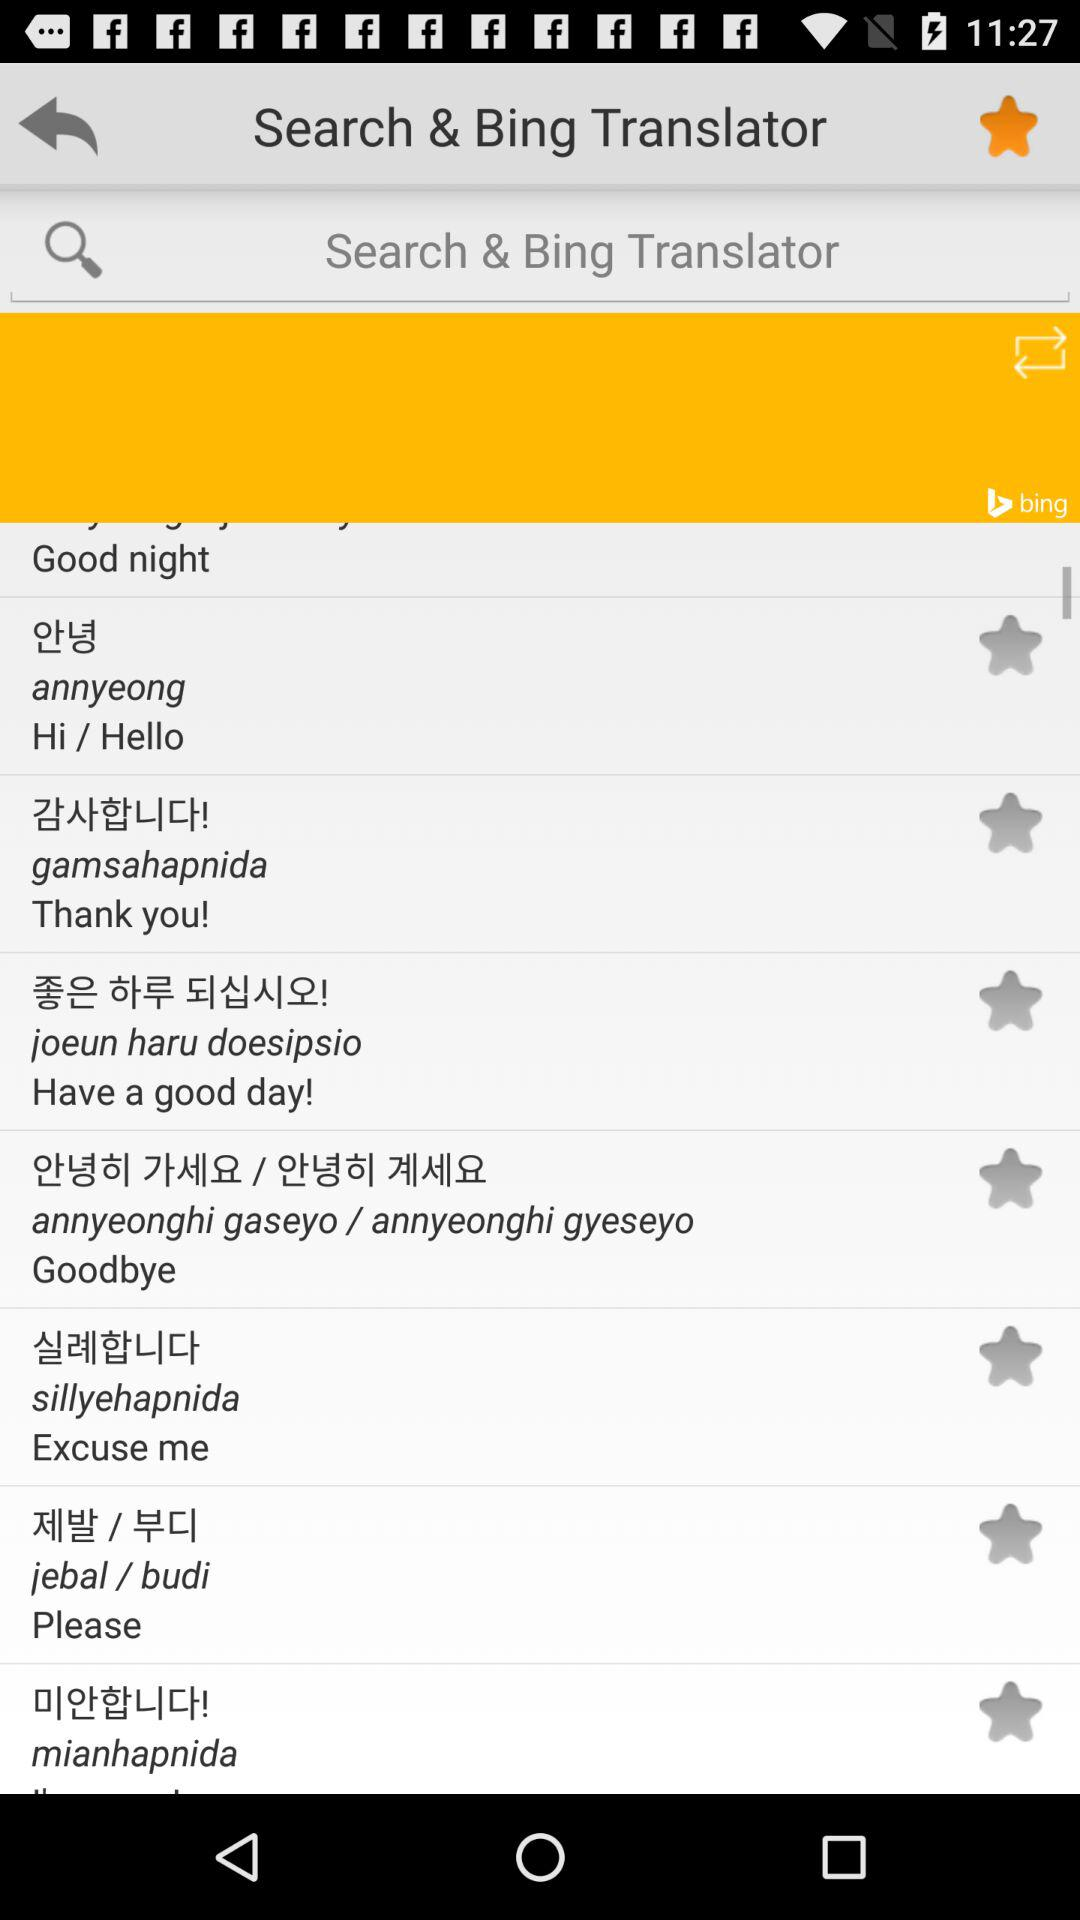What is the application Name? The application name is "Search & Bing Translator". 